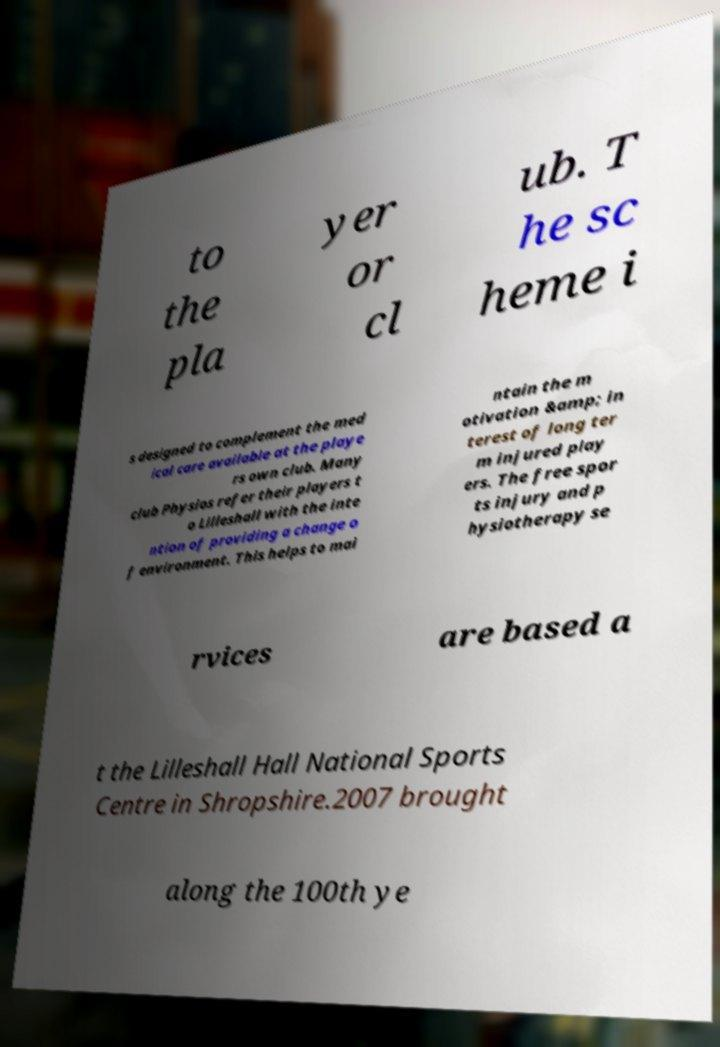Please identify and transcribe the text found in this image. to the pla yer or cl ub. T he sc heme i s designed to complement the med ical care available at the playe rs own club. Many club Physios refer their players t o Lilleshall with the inte ntion of providing a change o f environment. This helps to mai ntain the m otivation &amp; in terest of long ter m injured play ers. The free spor ts injury and p hysiotherapy se rvices are based a t the Lilleshall Hall National Sports Centre in Shropshire.2007 brought along the 100th ye 